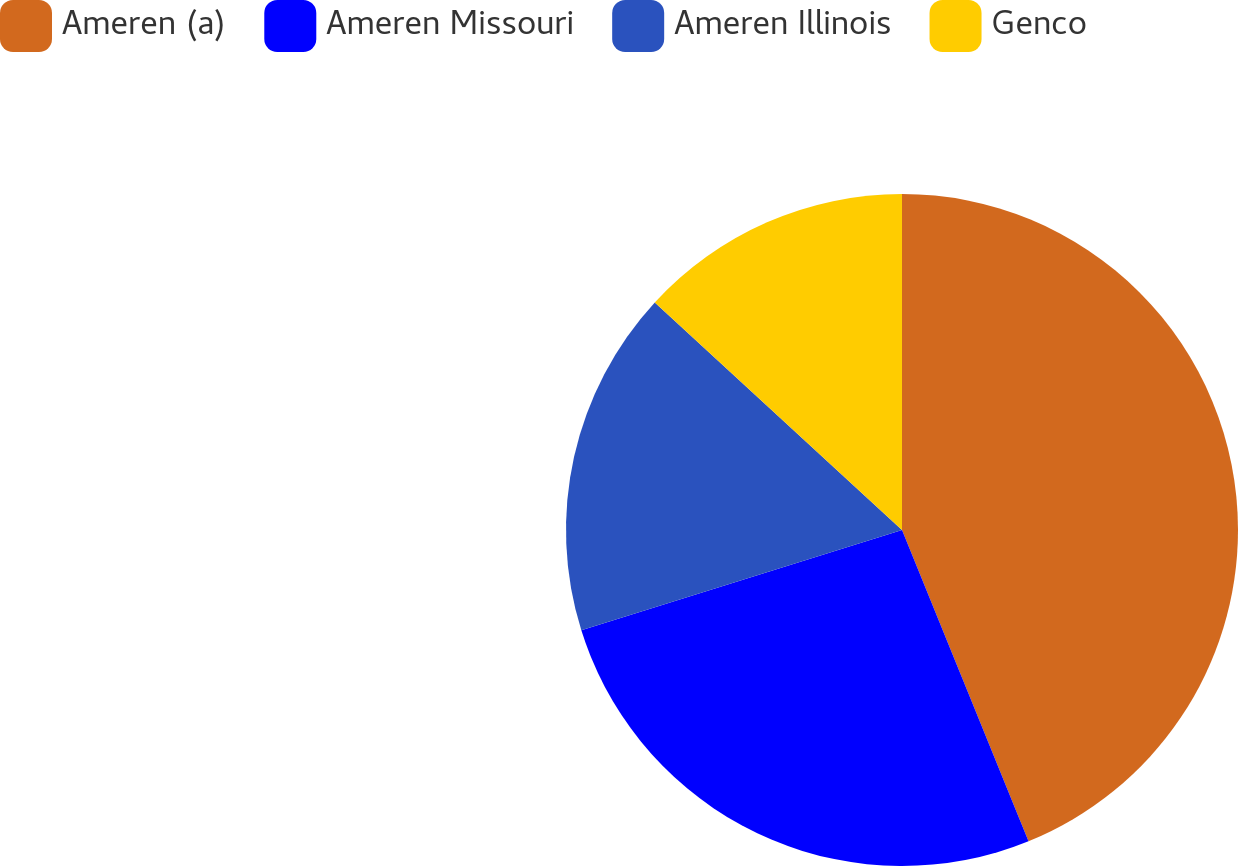Convert chart. <chart><loc_0><loc_0><loc_500><loc_500><pie_chart><fcel>Ameren (a)<fcel>Ameren Missouri<fcel>Ameren Illinois<fcel>Genco<nl><fcel>43.86%<fcel>26.32%<fcel>16.67%<fcel>13.16%<nl></chart> 